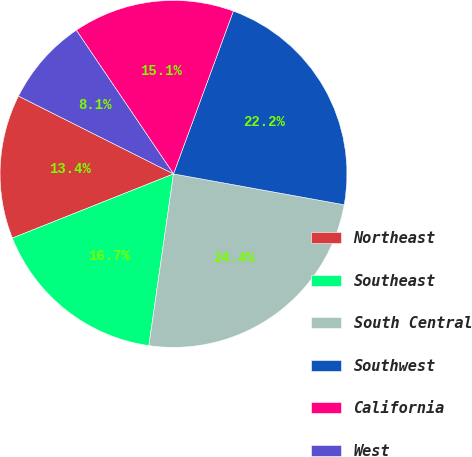Convert chart to OTSL. <chart><loc_0><loc_0><loc_500><loc_500><pie_chart><fcel>Northeast<fcel>Southeast<fcel>South Central<fcel>Southwest<fcel>California<fcel>West<nl><fcel>13.44%<fcel>16.7%<fcel>24.42%<fcel>22.24%<fcel>15.07%<fcel>8.13%<nl></chart> 